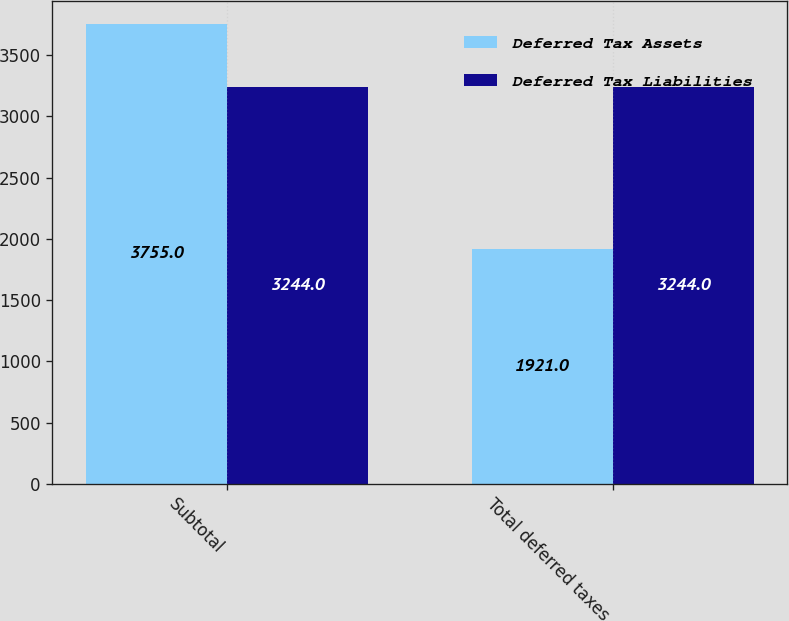<chart> <loc_0><loc_0><loc_500><loc_500><stacked_bar_chart><ecel><fcel>Subtotal<fcel>Total deferred taxes<nl><fcel>Deferred Tax Assets<fcel>3755<fcel>1921<nl><fcel>Deferred Tax Liabilities<fcel>3244<fcel>3244<nl></chart> 